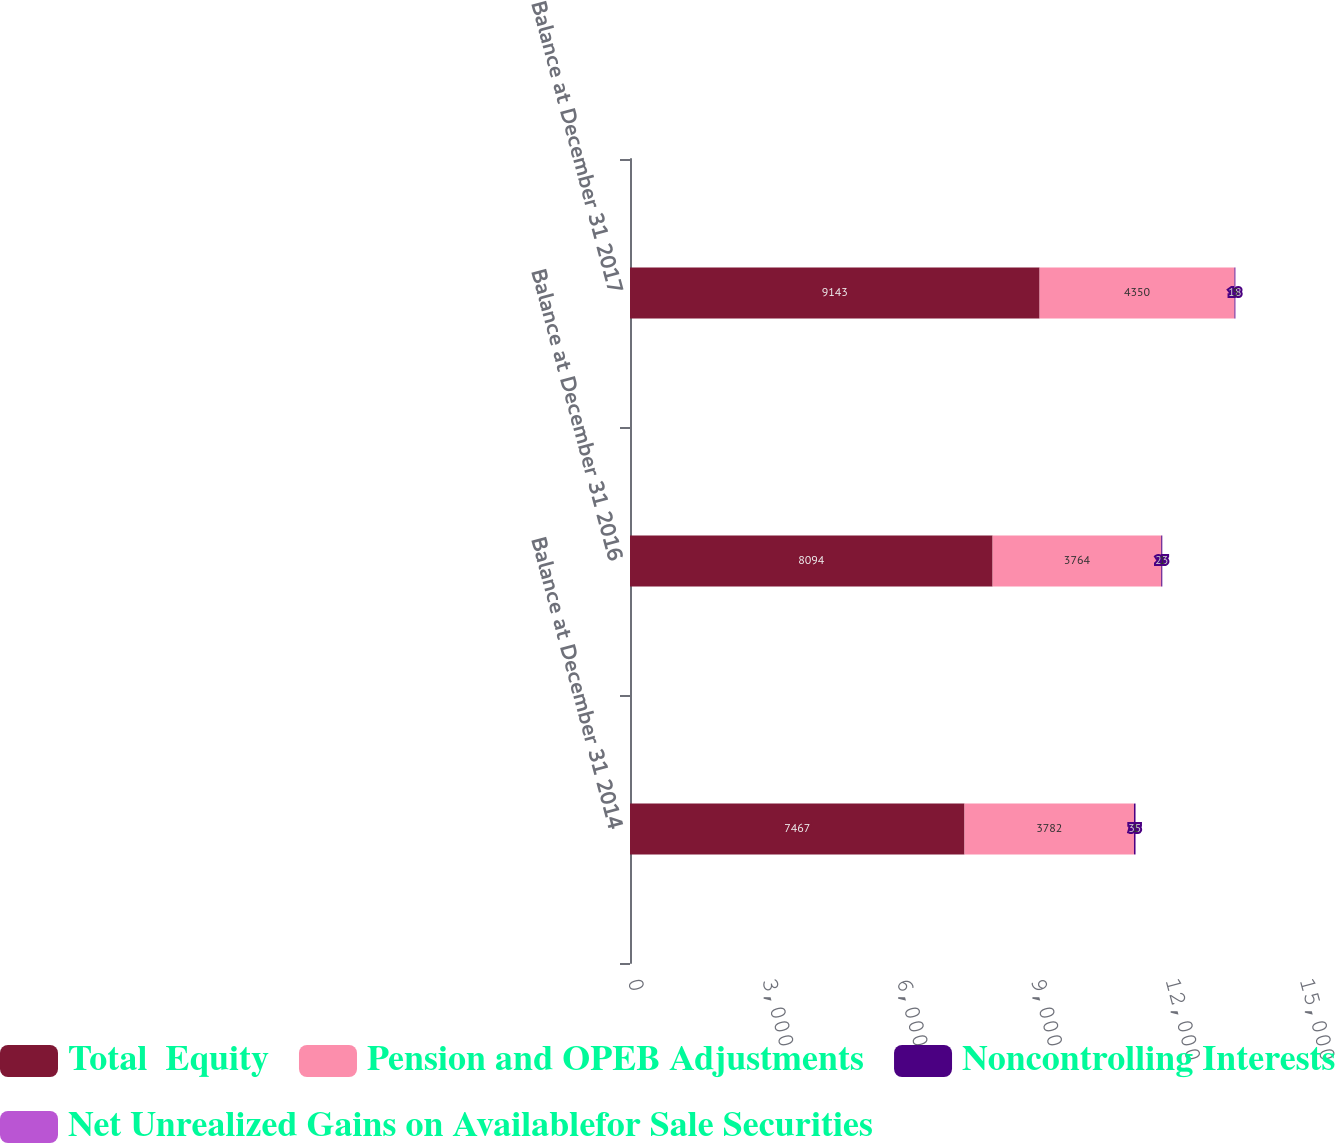Convert chart to OTSL. <chart><loc_0><loc_0><loc_500><loc_500><stacked_bar_chart><ecel><fcel>Balance at December 31 2014<fcel>Balance at December 31 2016<fcel>Balance at December 31 2017<nl><fcel>Total  Equity<fcel>7467<fcel>8094<fcel>9143<nl><fcel>Pension and OPEB Adjustments<fcel>3782<fcel>3764<fcel>4350<nl><fcel>Noncontrolling Interests<fcel>35<fcel>23<fcel>18<nl><fcel>Net Unrealized Gains on Availablefor Sale Securities<fcel>1<fcel>1<fcel>5<nl></chart> 